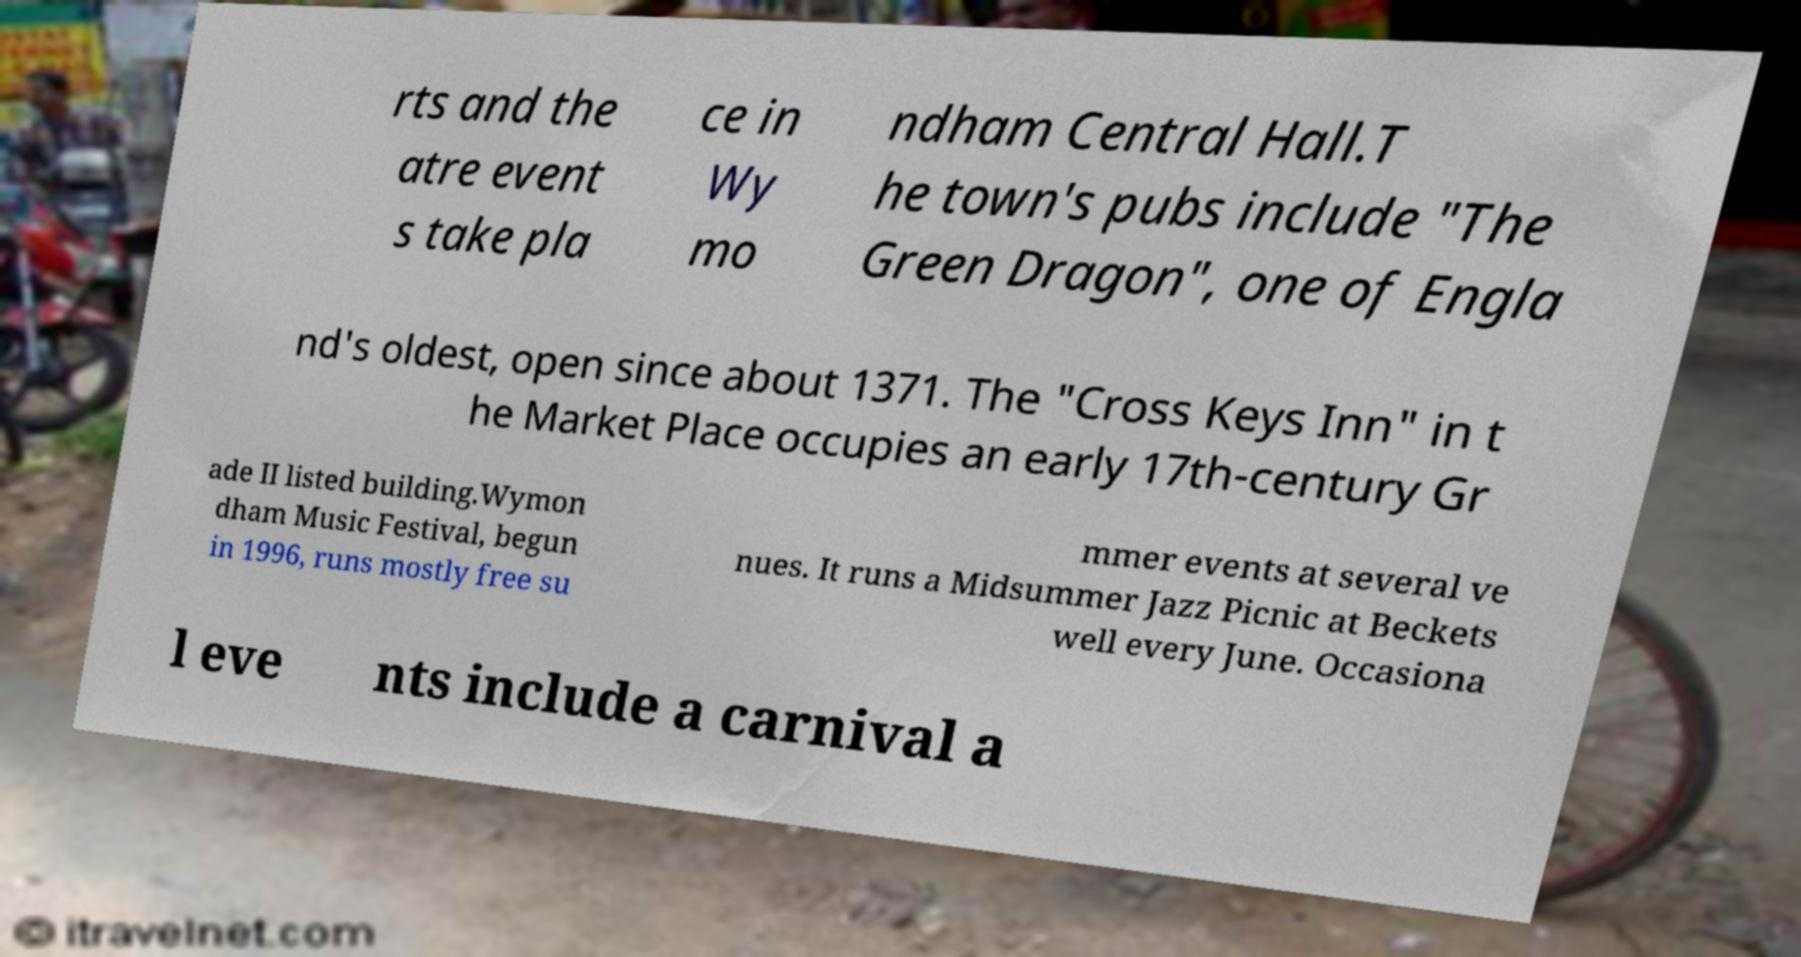Please read and relay the text visible in this image. What does it say? rts and the atre event s take pla ce in Wy mo ndham Central Hall.T he town's pubs include "The Green Dragon", one of Engla nd's oldest, open since about 1371. The "Cross Keys Inn" in t he Market Place occupies an early 17th-century Gr ade II listed building.Wymon dham Music Festival, begun in 1996, runs mostly free su mmer events at several ve nues. It runs a Midsummer Jazz Picnic at Beckets well every June. Occasiona l eve nts include a carnival a 